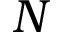Convert formula to latex. <formula><loc_0><loc_0><loc_500><loc_500>N</formula> 